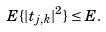Convert formula to latex. <formula><loc_0><loc_0><loc_500><loc_500>E \{ | t _ { j , k } | ^ { 2 } \} & \leq E .</formula> 